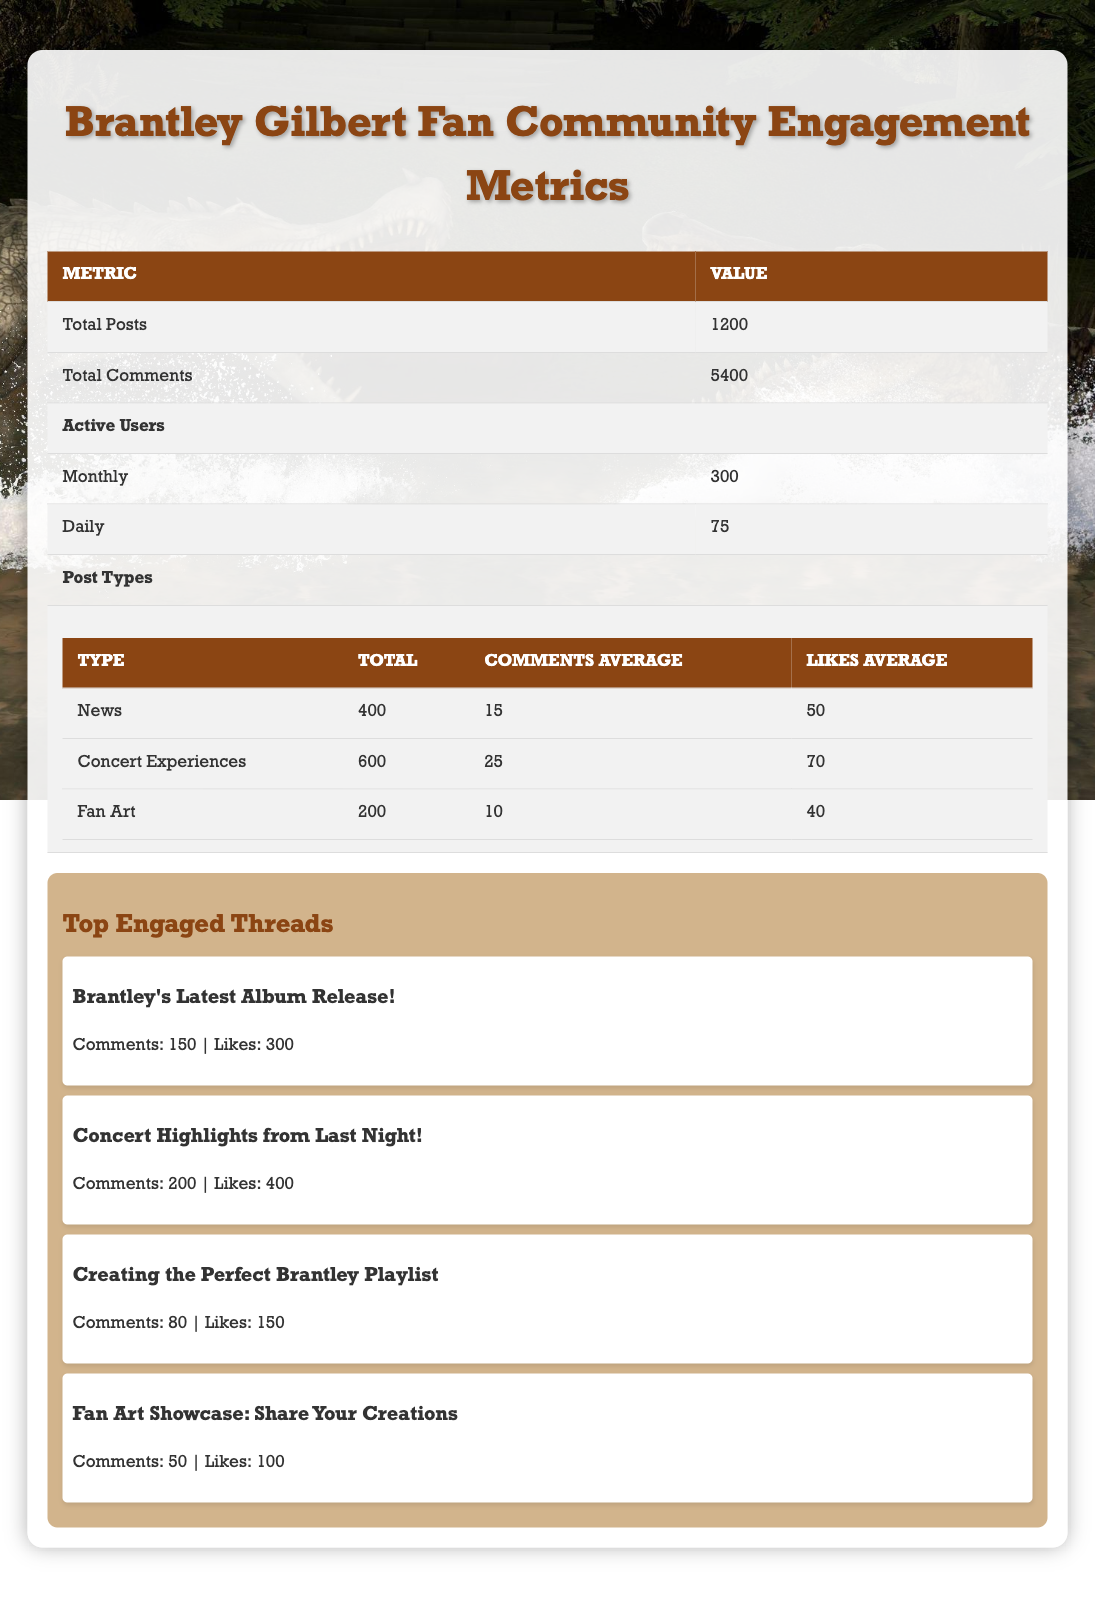What is the total number of posts in the community? The table directly states the total number of posts as 1200.
Answer: 1200 How many total comments are there in the fan community? The total number of comments is clearly listed in the table as 5400.
Answer: 5400 What type of post has the highest average number of likes? Looking at the "Likes Average" for each post type, "Concert Experiences" has the highest average at 70.
Answer: Concert Experiences Is the average number of comments for Fan Art posts greater than 15? The average comments for Fan Art posts is 10, which is less than 15. So, the statement is false.
Answer: No What is the total number of active users per month and per day combined? The monthly active users are 300 and daily active users are 75. Adding them gives 300 + 75 = 375 combined active users.
Answer: 375 Which thread has the most comments and how many likes does it have? The thread with the most comments is "Concert Highlights from Last Night!" with 200 comments and it has 400 likes.
Answer: Concert Highlights from Last Night! with 400 likes What percentage of the total posts are concert experience posts? To find the percentage of "Concert Experiences" posts: (600 / 1200) * 100 = 50%.
Answer: 50% Which post type has the least average comments and how many are there? By comparing the "Comments Average," Fan Art has the least average at 10 comments per post.
Answer: 10 How many more comments are there on Concert Experiences posts compared to Fan Art posts? The average comments for Concert Experiences is 25 and for Fan Art is 10. The difference is 25 - 10 = 15 more comments.
Answer: 15 Is it true that there are more Concert Experience posts than Fan Art posts? The table shows there are 600 Concert Experience posts and 200 Fan Art posts, meaning there are indeed more Concert Experience posts.
Answer: Yes 